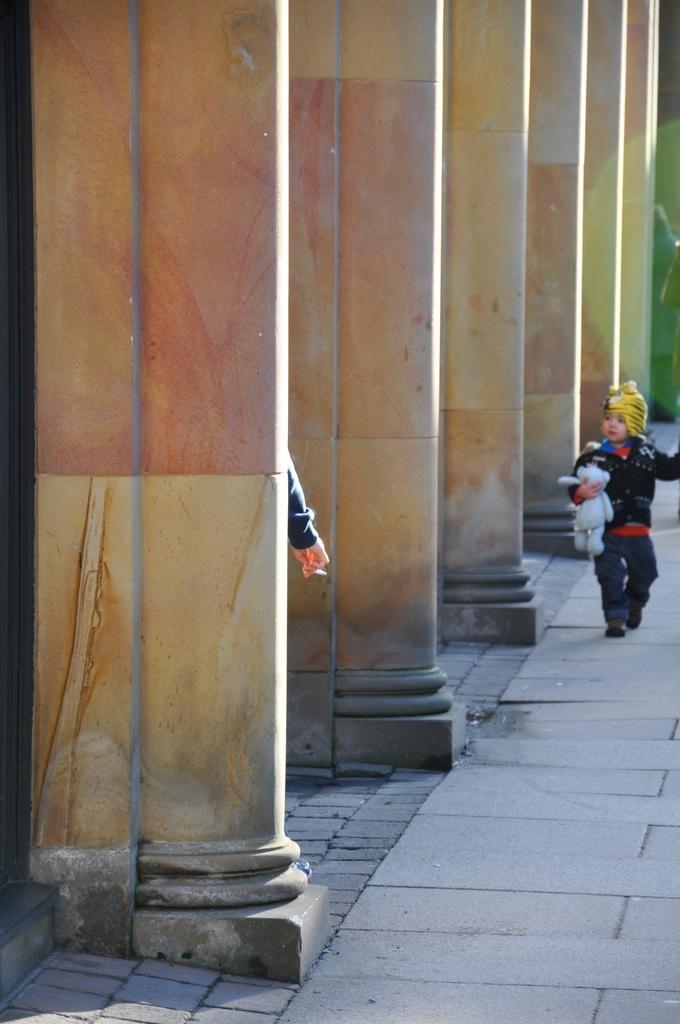How would you summarize this image in a sentence or two? In this image I can see the person wearing the black, red, blue and grey color dress and holding the toy. To the side of the person I can see many pillars and one more persons hand. 